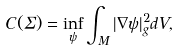<formula> <loc_0><loc_0><loc_500><loc_500>C ( \Sigma ) = \inf _ { \psi } \int _ { M } | \nabla \psi | _ { g } ^ { 2 } d V ,</formula> 